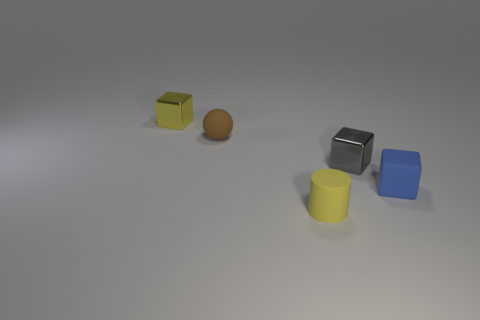Subtract all gray blocks. Subtract all brown balls. How many blocks are left? 2 Add 3 tiny gray metallic spheres. How many objects exist? 8 Subtract all balls. How many objects are left? 4 Add 1 yellow matte things. How many yellow matte things exist? 2 Subtract 1 yellow blocks. How many objects are left? 4 Subtract all tiny rubber cubes. Subtract all small brown cubes. How many objects are left? 4 Add 4 tiny gray blocks. How many tiny gray blocks are left? 5 